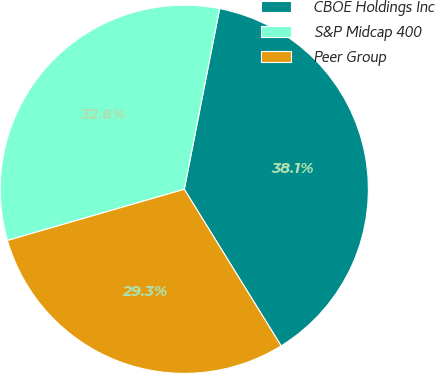Convert chart to OTSL. <chart><loc_0><loc_0><loc_500><loc_500><pie_chart><fcel>CBOE Holdings Inc<fcel>S&P Midcap 400<fcel>Peer Group<nl><fcel>38.11%<fcel>32.56%<fcel>29.33%<nl></chart> 